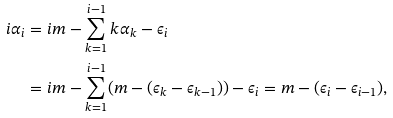Convert formula to latex. <formula><loc_0><loc_0><loc_500><loc_500>i \alpha _ { i } & = i m - \sum _ { k = 1 } ^ { i - 1 } k \alpha _ { k } - \epsilon _ { i } \\ & = i m - \sum _ { k = 1 } ^ { i - 1 } ( m - ( \epsilon _ { k } - \epsilon _ { k - 1 } ) ) - \epsilon _ { i } = m - ( \epsilon _ { i } - \epsilon _ { i - 1 } ) ,</formula> 